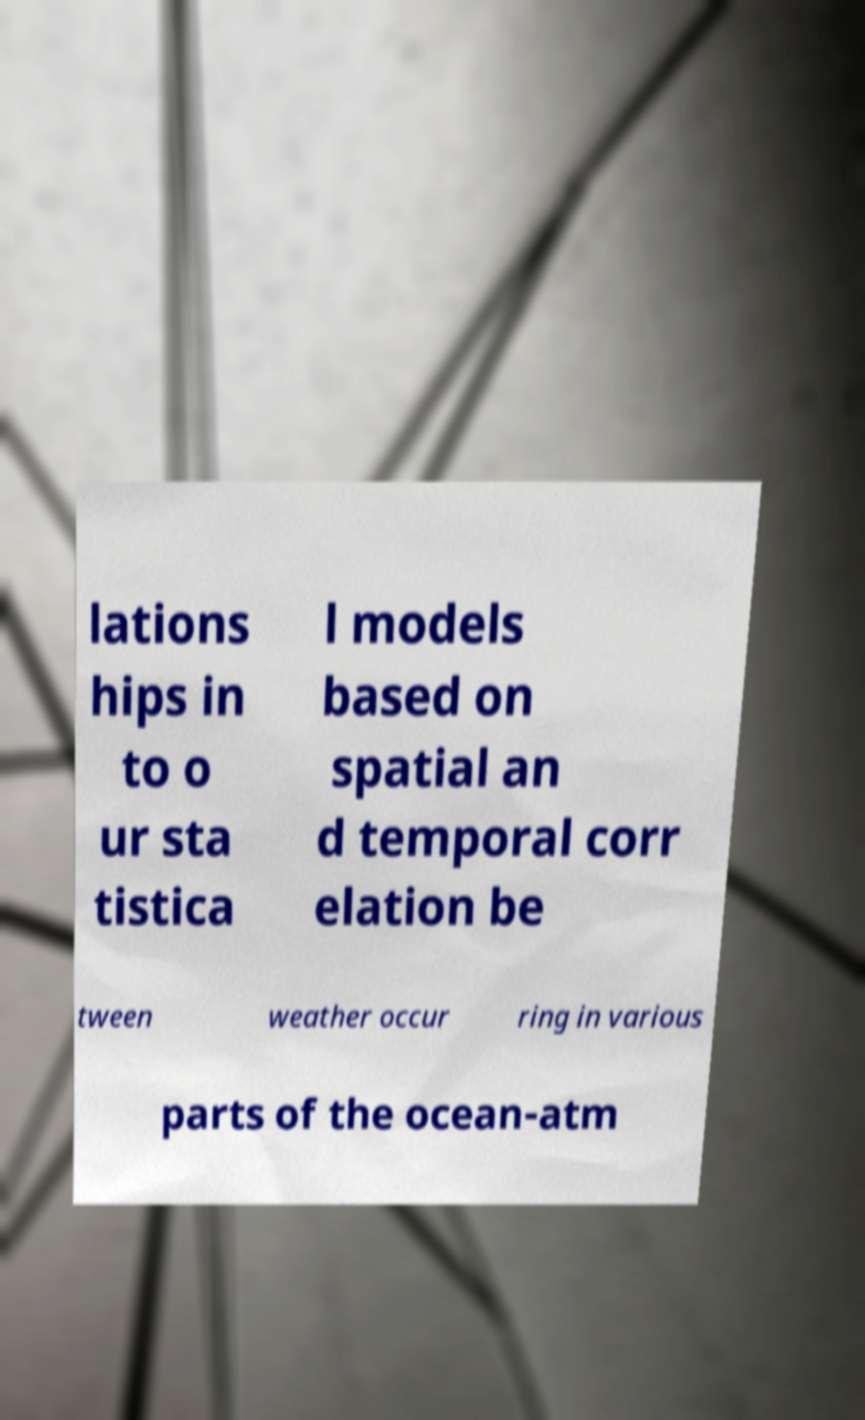Please identify and transcribe the text found in this image. lations hips in to o ur sta tistica l models based on spatial an d temporal corr elation be tween weather occur ring in various parts of the ocean-atm 